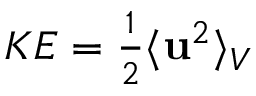<formula> <loc_0><loc_0><loc_500><loc_500>\begin{array} { r } { K E = \frac { 1 } { 2 } \langle u ^ { 2 } \rangle _ { V } } \end{array}</formula> 